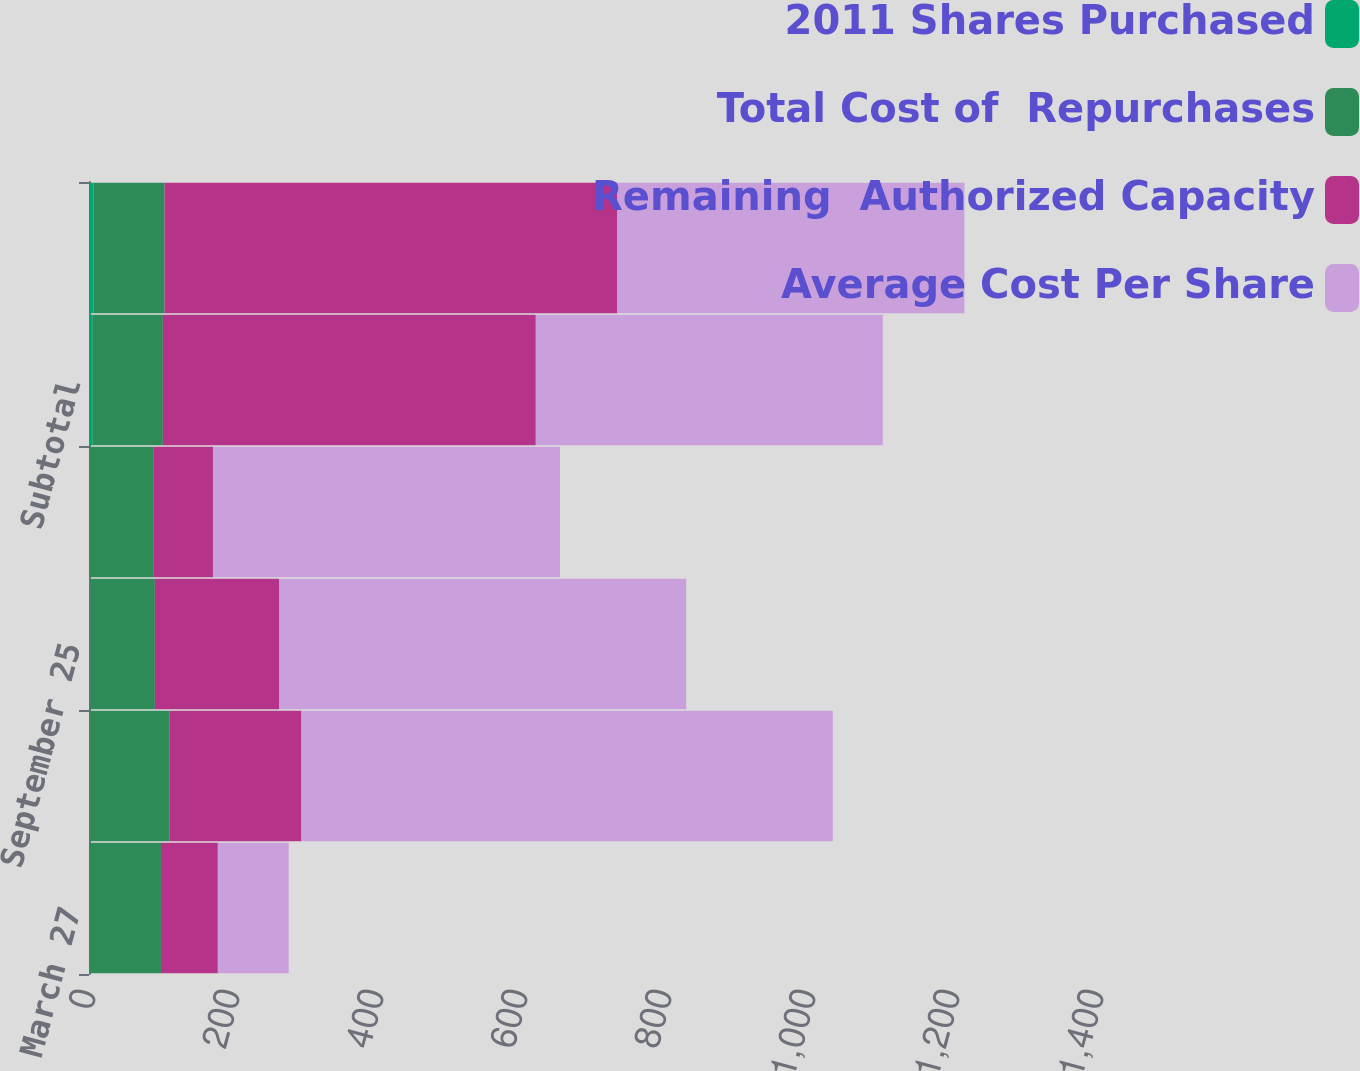<chart> <loc_0><loc_0><loc_500><loc_500><stacked_bar_chart><ecel><fcel>March 27<fcel>June 26<fcel>September 25<fcel>December 31<fcel>Subtotal<fcel>Total<nl><fcel>2011 Shares Purchased<fcel>0.8<fcel>1.6<fcel>1.9<fcel>1<fcel>5.3<fcel>6.4<nl><fcel>Total Cost of  Repurchases<fcel>99.14<fcel>110.49<fcel>89.55<fcel>88.17<fcel>97.26<fcel>98.46<nl><fcel>Remaining  Authorized Capacity<fcel>79<fcel>183<fcel>173<fcel>83<fcel>518<fcel>629<nl><fcel>Average Cost Per Share<fcel>98.46<fcel>738<fcel>565<fcel>482<fcel>482<fcel>482<nl></chart> 